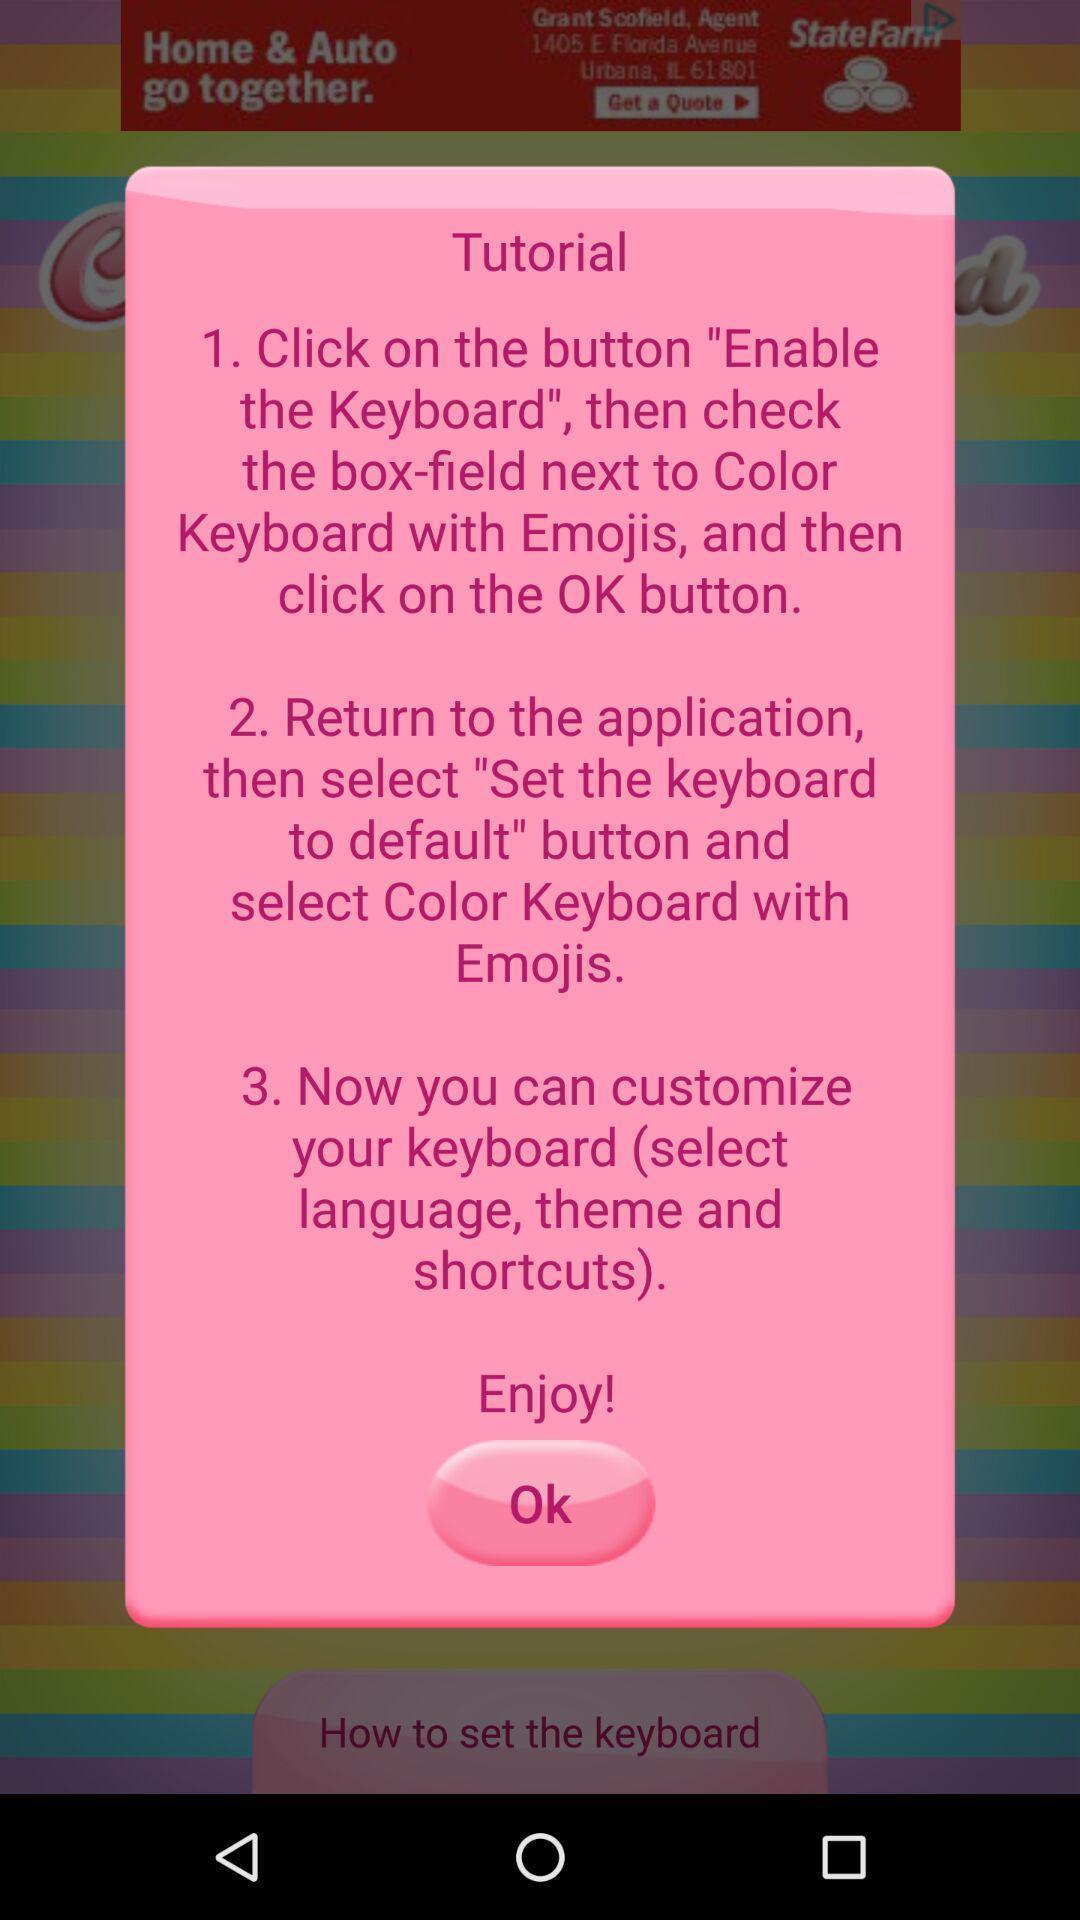Give me a narrative description of this picture. Popup showing tutorial. 